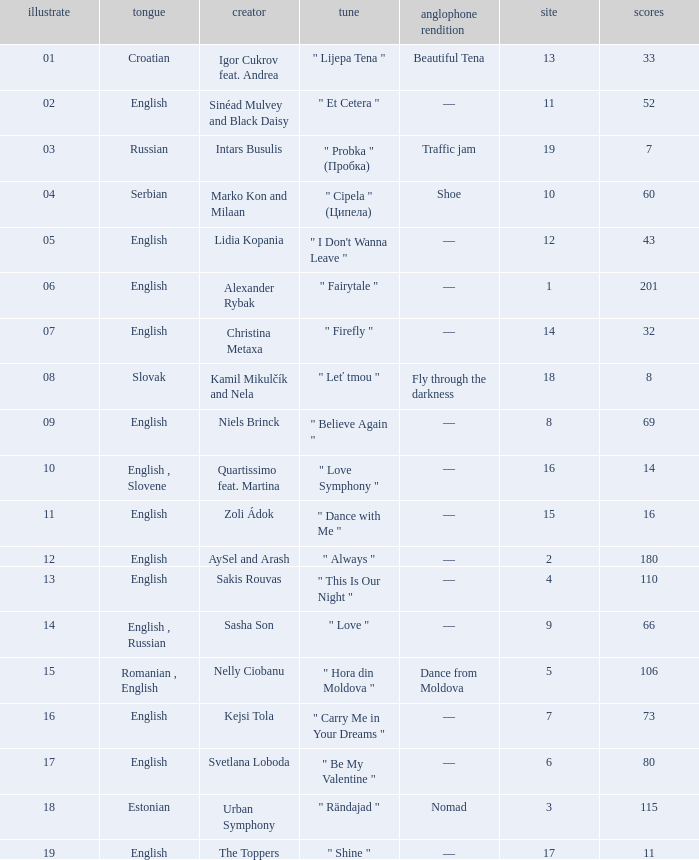What is the average Points when the artist is kamil mikulčík and nela, and the Place is larger than 18? None. 